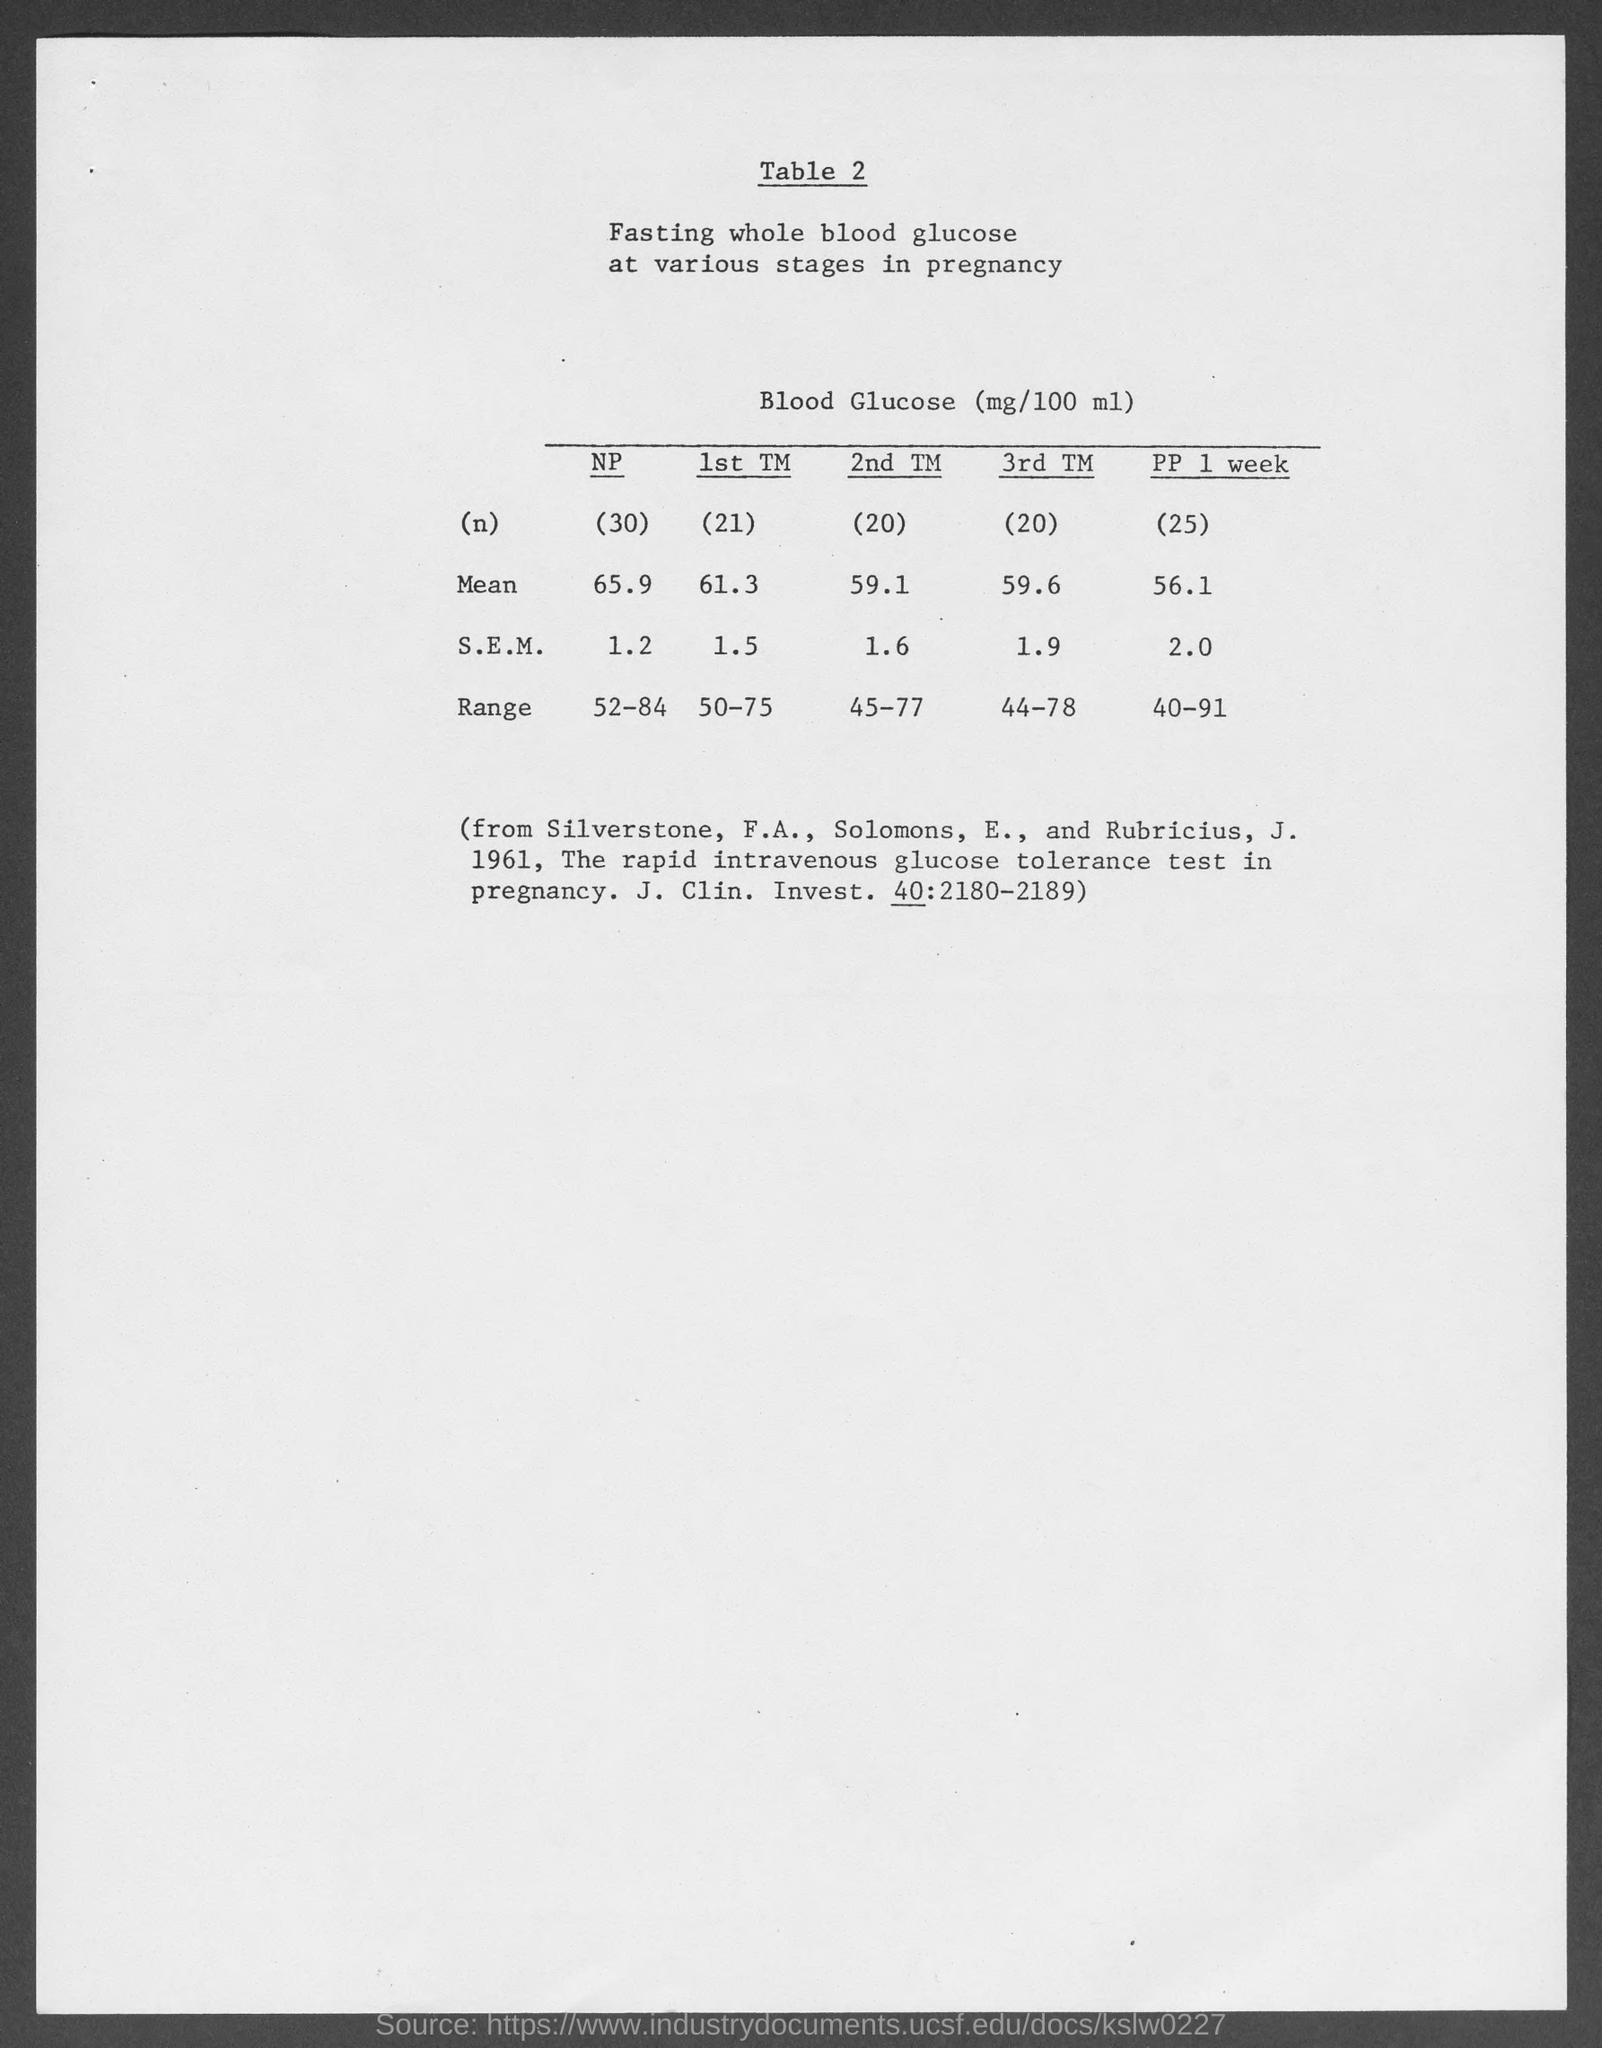What is the mean value of 1st TM? The mean fasting whole blood glucose level during the first trimester (1st TM) is 61.3 mg/100 ml, as documented in the table. 